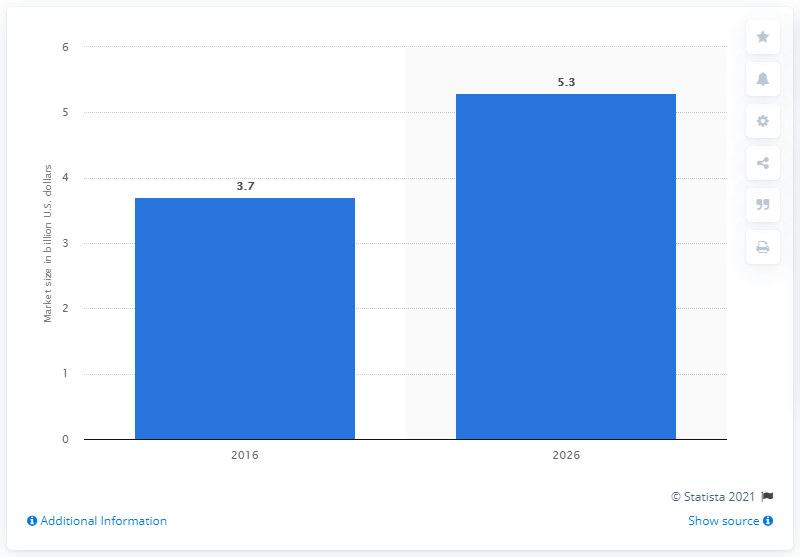Indicate a few pertinent items in this graphic. The estimated value of the global human growth hormone market in 2016 was 3.7... 